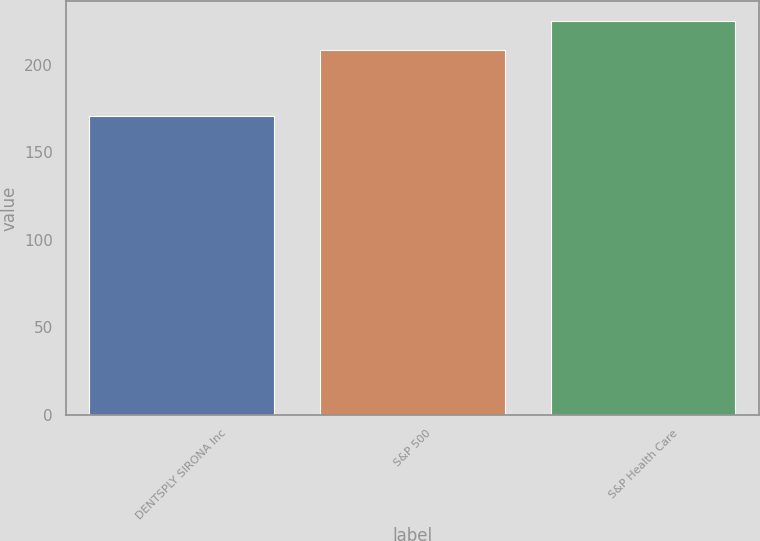Convert chart to OTSL. <chart><loc_0><loc_0><loc_500><loc_500><bar_chart><fcel>DENTSPLY SIRONA Inc<fcel>S&P 500<fcel>S&P Health Care<nl><fcel>170.79<fcel>208.14<fcel>225.13<nl></chart> 